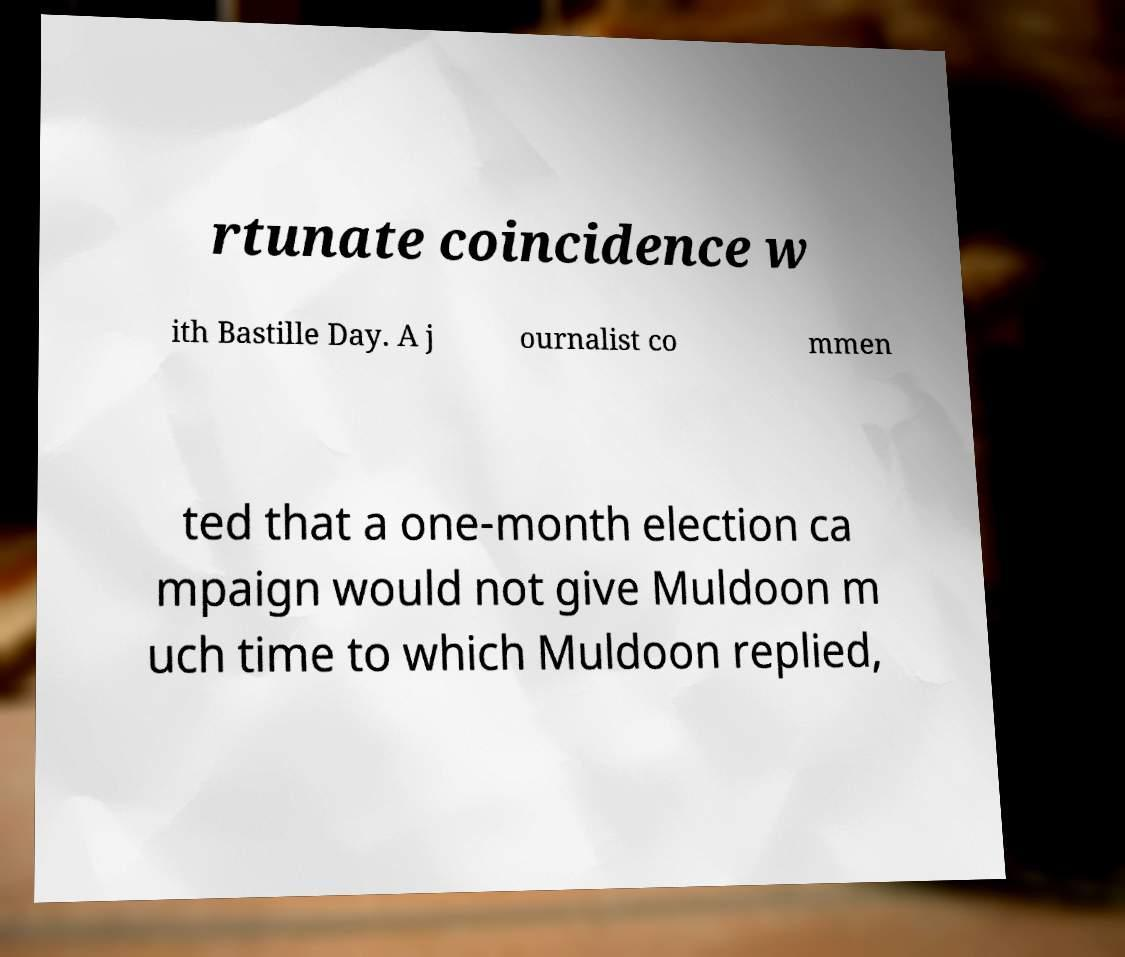There's text embedded in this image that I need extracted. Can you transcribe it verbatim? rtunate coincidence w ith Bastille Day. A j ournalist co mmen ted that a one-month election ca mpaign would not give Muldoon m uch time to which Muldoon replied, 